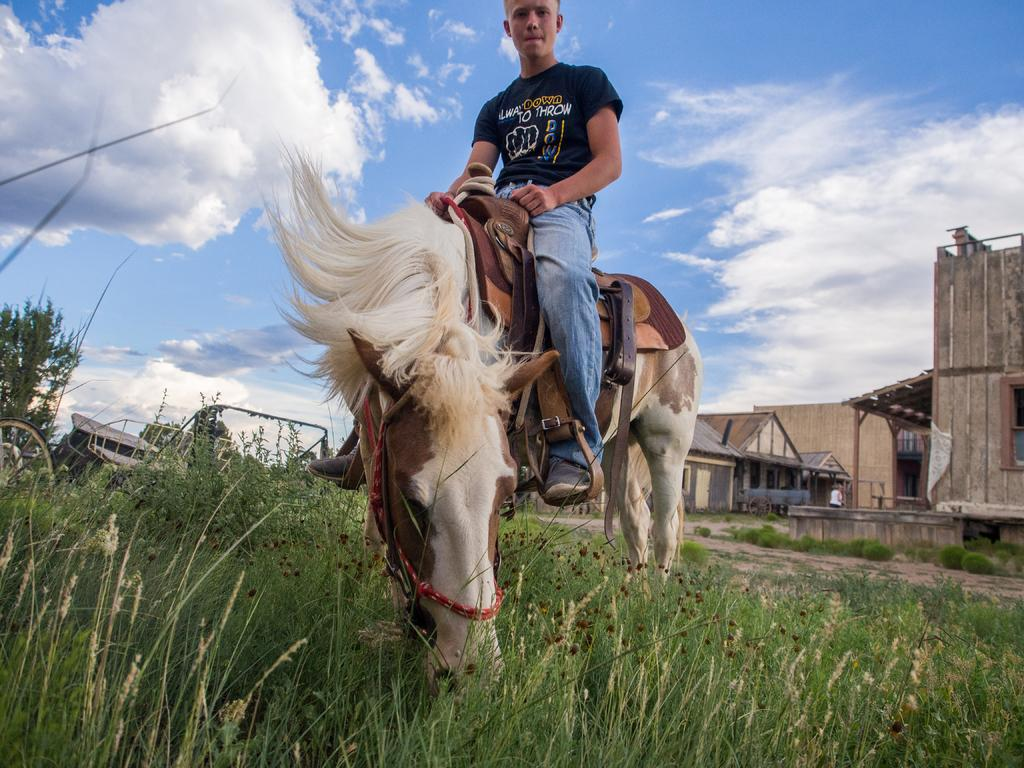Who is the main subject in the image? There is a boy in the image. What is the boy doing in the image? The boy is standing on a white horse. What is the horse standing on? The horse is on grass. What can be seen on the right side of the image? There are houses on the right side of the image. What is visible at the top of the image? The sky is visible at the top of the image. What type of stew is being prepared in the image? There is no stew present in the image; it features a boy standing on a white horse on grass, with houses on the right side and the sky visible at the top. 